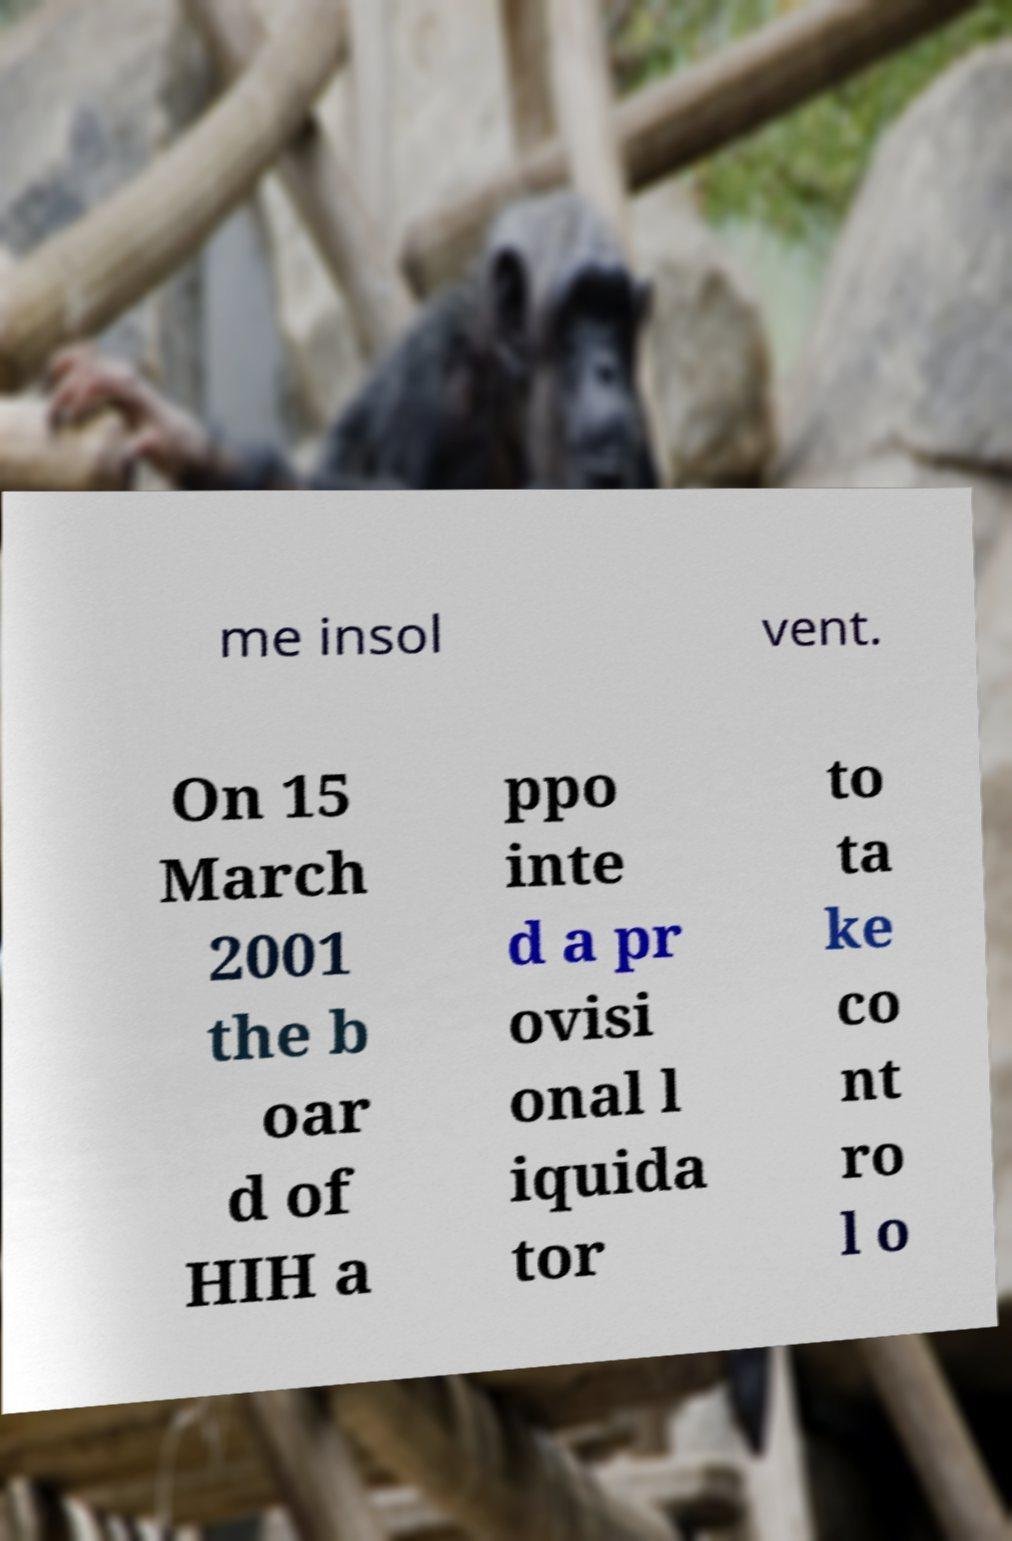Could you assist in decoding the text presented in this image and type it out clearly? me insol vent. On 15 March 2001 the b oar d of HIH a ppo inte d a pr ovisi onal l iquida tor to ta ke co nt ro l o 